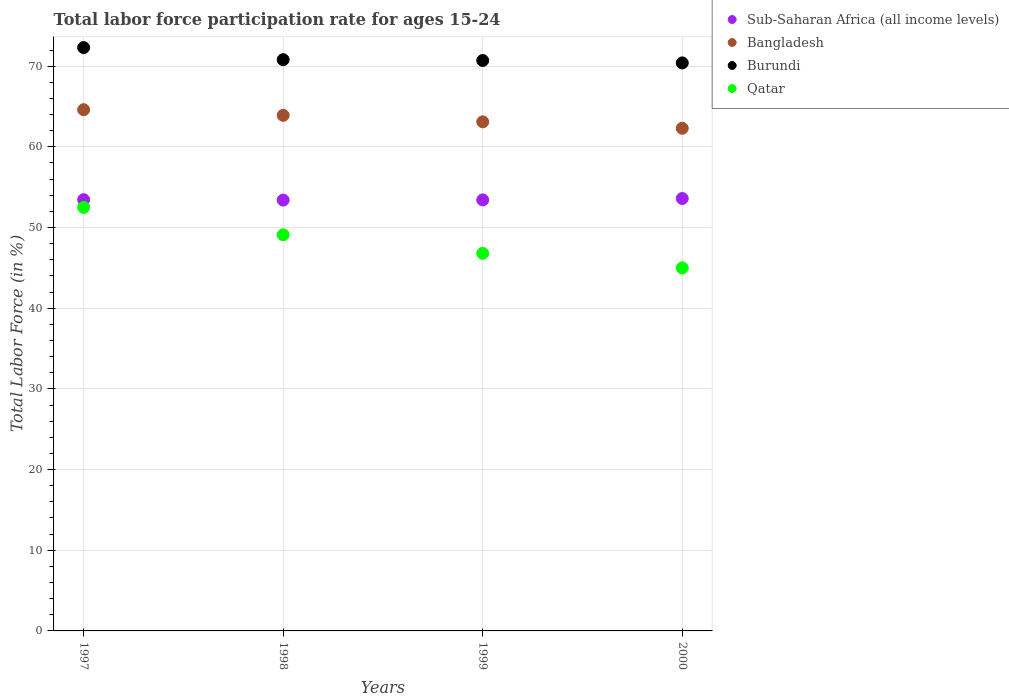How many different coloured dotlines are there?
Your response must be concise. 4. What is the labor force participation rate in Bangladesh in 1997?
Your answer should be compact. 64.6. Across all years, what is the maximum labor force participation rate in Bangladesh?
Keep it short and to the point. 64.6. Across all years, what is the minimum labor force participation rate in Bangladesh?
Your answer should be compact. 62.3. In which year was the labor force participation rate in Burundi maximum?
Give a very brief answer. 1997. What is the total labor force participation rate in Qatar in the graph?
Offer a terse response. 193.4. What is the difference between the labor force participation rate in Qatar in 1998 and that in 2000?
Provide a succinct answer. 4.1. What is the difference between the labor force participation rate in Bangladesh in 1999 and the labor force participation rate in Qatar in 2000?
Your answer should be compact. 18.1. What is the average labor force participation rate in Sub-Saharan Africa (all income levels) per year?
Your response must be concise. 53.47. In the year 2000, what is the difference between the labor force participation rate in Qatar and labor force participation rate in Sub-Saharan Africa (all income levels)?
Offer a very short reply. -8.6. What is the ratio of the labor force participation rate in Burundi in 1997 to that in 1998?
Offer a terse response. 1.02. Is the labor force participation rate in Burundi in 1998 less than that in 1999?
Your response must be concise. No. What is the difference between the highest and the second highest labor force participation rate in Sub-Saharan Africa (all income levels)?
Your response must be concise. 0.15. What is the difference between the highest and the lowest labor force participation rate in Bangladesh?
Your answer should be compact. 2.3. Does the labor force participation rate in Bangladesh monotonically increase over the years?
Ensure brevity in your answer.  No. Does the graph contain any zero values?
Your response must be concise. No. Does the graph contain grids?
Your response must be concise. Yes. What is the title of the graph?
Offer a terse response. Total labor force participation rate for ages 15-24. What is the label or title of the X-axis?
Your answer should be very brief. Years. What is the label or title of the Y-axis?
Your answer should be very brief. Total Labor Force (in %). What is the Total Labor Force (in %) in Sub-Saharan Africa (all income levels) in 1997?
Provide a succinct answer. 53.45. What is the Total Labor Force (in %) of Bangladesh in 1997?
Make the answer very short. 64.6. What is the Total Labor Force (in %) of Burundi in 1997?
Keep it short and to the point. 72.3. What is the Total Labor Force (in %) of Qatar in 1997?
Offer a very short reply. 52.5. What is the Total Labor Force (in %) of Sub-Saharan Africa (all income levels) in 1998?
Make the answer very short. 53.4. What is the Total Labor Force (in %) in Bangladesh in 1998?
Make the answer very short. 63.9. What is the Total Labor Force (in %) of Burundi in 1998?
Offer a very short reply. 70.8. What is the Total Labor Force (in %) in Qatar in 1998?
Your response must be concise. 49.1. What is the Total Labor Force (in %) of Sub-Saharan Africa (all income levels) in 1999?
Offer a very short reply. 53.42. What is the Total Labor Force (in %) of Bangladesh in 1999?
Offer a terse response. 63.1. What is the Total Labor Force (in %) in Burundi in 1999?
Your response must be concise. 70.7. What is the Total Labor Force (in %) in Qatar in 1999?
Ensure brevity in your answer.  46.8. What is the Total Labor Force (in %) of Sub-Saharan Africa (all income levels) in 2000?
Give a very brief answer. 53.6. What is the Total Labor Force (in %) in Bangladesh in 2000?
Your answer should be very brief. 62.3. What is the Total Labor Force (in %) in Burundi in 2000?
Ensure brevity in your answer.  70.4. Across all years, what is the maximum Total Labor Force (in %) in Sub-Saharan Africa (all income levels)?
Provide a succinct answer. 53.6. Across all years, what is the maximum Total Labor Force (in %) of Bangladesh?
Ensure brevity in your answer.  64.6. Across all years, what is the maximum Total Labor Force (in %) in Burundi?
Ensure brevity in your answer.  72.3. Across all years, what is the maximum Total Labor Force (in %) in Qatar?
Offer a very short reply. 52.5. Across all years, what is the minimum Total Labor Force (in %) in Sub-Saharan Africa (all income levels)?
Ensure brevity in your answer.  53.4. Across all years, what is the minimum Total Labor Force (in %) of Bangladesh?
Provide a succinct answer. 62.3. Across all years, what is the minimum Total Labor Force (in %) of Burundi?
Offer a very short reply. 70.4. What is the total Total Labor Force (in %) in Sub-Saharan Africa (all income levels) in the graph?
Your answer should be very brief. 213.86. What is the total Total Labor Force (in %) of Bangladesh in the graph?
Offer a very short reply. 253.9. What is the total Total Labor Force (in %) of Burundi in the graph?
Provide a short and direct response. 284.2. What is the total Total Labor Force (in %) of Qatar in the graph?
Give a very brief answer. 193.4. What is the difference between the Total Labor Force (in %) in Sub-Saharan Africa (all income levels) in 1997 and that in 1998?
Offer a very short reply. 0.05. What is the difference between the Total Labor Force (in %) of Bangladesh in 1997 and that in 1998?
Provide a succinct answer. 0.7. What is the difference between the Total Labor Force (in %) in Qatar in 1997 and that in 1998?
Provide a succinct answer. 3.4. What is the difference between the Total Labor Force (in %) in Sub-Saharan Africa (all income levels) in 1997 and that in 1999?
Your answer should be compact. 0.03. What is the difference between the Total Labor Force (in %) of Burundi in 1997 and that in 1999?
Your answer should be very brief. 1.6. What is the difference between the Total Labor Force (in %) in Sub-Saharan Africa (all income levels) in 1997 and that in 2000?
Keep it short and to the point. -0.15. What is the difference between the Total Labor Force (in %) of Bangladesh in 1997 and that in 2000?
Provide a short and direct response. 2.3. What is the difference between the Total Labor Force (in %) of Burundi in 1997 and that in 2000?
Ensure brevity in your answer.  1.9. What is the difference between the Total Labor Force (in %) of Sub-Saharan Africa (all income levels) in 1998 and that in 1999?
Provide a succinct answer. -0.02. What is the difference between the Total Labor Force (in %) of Burundi in 1998 and that in 1999?
Your answer should be very brief. 0.1. What is the difference between the Total Labor Force (in %) in Sub-Saharan Africa (all income levels) in 1998 and that in 2000?
Offer a terse response. -0.2. What is the difference between the Total Labor Force (in %) of Sub-Saharan Africa (all income levels) in 1999 and that in 2000?
Your answer should be compact. -0.18. What is the difference between the Total Labor Force (in %) of Sub-Saharan Africa (all income levels) in 1997 and the Total Labor Force (in %) of Bangladesh in 1998?
Offer a very short reply. -10.45. What is the difference between the Total Labor Force (in %) of Sub-Saharan Africa (all income levels) in 1997 and the Total Labor Force (in %) of Burundi in 1998?
Offer a very short reply. -17.35. What is the difference between the Total Labor Force (in %) in Sub-Saharan Africa (all income levels) in 1997 and the Total Labor Force (in %) in Qatar in 1998?
Give a very brief answer. 4.35. What is the difference between the Total Labor Force (in %) of Bangladesh in 1997 and the Total Labor Force (in %) of Burundi in 1998?
Provide a short and direct response. -6.2. What is the difference between the Total Labor Force (in %) of Bangladesh in 1997 and the Total Labor Force (in %) of Qatar in 1998?
Offer a terse response. 15.5. What is the difference between the Total Labor Force (in %) in Burundi in 1997 and the Total Labor Force (in %) in Qatar in 1998?
Your answer should be very brief. 23.2. What is the difference between the Total Labor Force (in %) of Sub-Saharan Africa (all income levels) in 1997 and the Total Labor Force (in %) of Bangladesh in 1999?
Offer a very short reply. -9.65. What is the difference between the Total Labor Force (in %) of Sub-Saharan Africa (all income levels) in 1997 and the Total Labor Force (in %) of Burundi in 1999?
Give a very brief answer. -17.25. What is the difference between the Total Labor Force (in %) in Sub-Saharan Africa (all income levels) in 1997 and the Total Labor Force (in %) in Qatar in 1999?
Provide a short and direct response. 6.65. What is the difference between the Total Labor Force (in %) of Bangladesh in 1997 and the Total Labor Force (in %) of Burundi in 1999?
Your response must be concise. -6.1. What is the difference between the Total Labor Force (in %) of Bangladesh in 1997 and the Total Labor Force (in %) of Qatar in 1999?
Make the answer very short. 17.8. What is the difference between the Total Labor Force (in %) in Burundi in 1997 and the Total Labor Force (in %) in Qatar in 1999?
Offer a very short reply. 25.5. What is the difference between the Total Labor Force (in %) of Sub-Saharan Africa (all income levels) in 1997 and the Total Labor Force (in %) of Bangladesh in 2000?
Your answer should be very brief. -8.85. What is the difference between the Total Labor Force (in %) in Sub-Saharan Africa (all income levels) in 1997 and the Total Labor Force (in %) in Burundi in 2000?
Offer a very short reply. -16.95. What is the difference between the Total Labor Force (in %) in Sub-Saharan Africa (all income levels) in 1997 and the Total Labor Force (in %) in Qatar in 2000?
Make the answer very short. 8.45. What is the difference between the Total Labor Force (in %) in Bangladesh in 1997 and the Total Labor Force (in %) in Qatar in 2000?
Your answer should be compact. 19.6. What is the difference between the Total Labor Force (in %) of Burundi in 1997 and the Total Labor Force (in %) of Qatar in 2000?
Your answer should be compact. 27.3. What is the difference between the Total Labor Force (in %) in Sub-Saharan Africa (all income levels) in 1998 and the Total Labor Force (in %) in Bangladesh in 1999?
Your response must be concise. -9.7. What is the difference between the Total Labor Force (in %) of Sub-Saharan Africa (all income levels) in 1998 and the Total Labor Force (in %) of Burundi in 1999?
Give a very brief answer. -17.3. What is the difference between the Total Labor Force (in %) in Sub-Saharan Africa (all income levels) in 1998 and the Total Labor Force (in %) in Qatar in 1999?
Ensure brevity in your answer.  6.6. What is the difference between the Total Labor Force (in %) in Bangladesh in 1998 and the Total Labor Force (in %) in Burundi in 1999?
Provide a succinct answer. -6.8. What is the difference between the Total Labor Force (in %) in Bangladesh in 1998 and the Total Labor Force (in %) in Qatar in 1999?
Your response must be concise. 17.1. What is the difference between the Total Labor Force (in %) of Burundi in 1998 and the Total Labor Force (in %) of Qatar in 1999?
Keep it short and to the point. 24. What is the difference between the Total Labor Force (in %) of Sub-Saharan Africa (all income levels) in 1998 and the Total Labor Force (in %) of Bangladesh in 2000?
Offer a very short reply. -8.9. What is the difference between the Total Labor Force (in %) in Sub-Saharan Africa (all income levels) in 1998 and the Total Labor Force (in %) in Burundi in 2000?
Give a very brief answer. -17. What is the difference between the Total Labor Force (in %) in Sub-Saharan Africa (all income levels) in 1998 and the Total Labor Force (in %) in Qatar in 2000?
Your response must be concise. 8.4. What is the difference between the Total Labor Force (in %) in Bangladesh in 1998 and the Total Labor Force (in %) in Burundi in 2000?
Keep it short and to the point. -6.5. What is the difference between the Total Labor Force (in %) in Burundi in 1998 and the Total Labor Force (in %) in Qatar in 2000?
Provide a succinct answer. 25.8. What is the difference between the Total Labor Force (in %) of Sub-Saharan Africa (all income levels) in 1999 and the Total Labor Force (in %) of Bangladesh in 2000?
Keep it short and to the point. -8.88. What is the difference between the Total Labor Force (in %) of Sub-Saharan Africa (all income levels) in 1999 and the Total Labor Force (in %) of Burundi in 2000?
Offer a very short reply. -16.98. What is the difference between the Total Labor Force (in %) in Sub-Saharan Africa (all income levels) in 1999 and the Total Labor Force (in %) in Qatar in 2000?
Ensure brevity in your answer.  8.42. What is the difference between the Total Labor Force (in %) in Burundi in 1999 and the Total Labor Force (in %) in Qatar in 2000?
Offer a terse response. 25.7. What is the average Total Labor Force (in %) of Sub-Saharan Africa (all income levels) per year?
Keep it short and to the point. 53.47. What is the average Total Labor Force (in %) of Bangladesh per year?
Keep it short and to the point. 63.48. What is the average Total Labor Force (in %) of Burundi per year?
Keep it short and to the point. 71.05. What is the average Total Labor Force (in %) in Qatar per year?
Your answer should be compact. 48.35. In the year 1997, what is the difference between the Total Labor Force (in %) in Sub-Saharan Africa (all income levels) and Total Labor Force (in %) in Bangladesh?
Make the answer very short. -11.15. In the year 1997, what is the difference between the Total Labor Force (in %) of Sub-Saharan Africa (all income levels) and Total Labor Force (in %) of Burundi?
Keep it short and to the point. -18.85. In the year 1997, what is the difference between the Total Labor Force (in %) of Sub-Saharan Africa (all income levels) and Total Labor Force (in %) of Qatar?
Your answer should be very brief. 0.95. In the year 1997, what is the difference between the Total Labor Force (in %) of Bangladesh and Total Labor Force (in %) of Burundi?
Provide a short and direct response. -7.7. In the year 1997, what is the difference between the Total Labor Force (in %) of Burundi and Total Labor Force (in %) of Qatar?
Your answer should be compact. 19.8. In the year 1998, what is the difference between the Total Labor Force (in %) in Sub-Saharan Africa (all income levels) and Total Labor Force (in %) in Bangladesh?
Your response must be concise. -10.5. In the year 1998, what is the difference between the Total Labor Force (in %) in Sub-Saharan Africa (all income levels) and Total Labor Force (in %) in Burundi?
Make the answer very short. -17.4. In the year 1998, what is the difference between the Total Labor Force (in %) in Sub-Saharan Africa (all income levels) and Total Labor Force (in %) in Qatar?
Provide a short and direct response. 4.3. In the year 1998, what is the difference between the Total Labor Force (in %) in Burundi and Total Labor Force (in %) in Qatar?
Your answer should be very brief. 21.7. In the year 1999, what is the difference between the Total Labor Force (in %) of Sub-Saharan Africa (all income levels) and Total Labor Force (in %) of Bangladesh?
Keep it short and to the point. -9.68. In the year 1999, what is the difference between the Total Labor Force (in %) in Sub-Saharan Africa (all income levels) and Total Labor Force (in %) in Burundi?
Give a very brief answer. -17.28. In the year 1999, what is the difference between the Total Labor Force (in %) in Sub-Saharan Africa (all income levels) and Total Labor Force (in %) in Qatar?
Your answer should be compact. 6.62. In the year 1999, what is the difference between the Total Labor Force (in %) in Burundi and Total Labor Force (in %) in Qatar?
Your answer should be compact. 23.9. In the year 2000, what is the difference between the Total Labor Force (in %) in Sub-Saharan Africa (all income levels) and Total Labor Force (in %) in Bangladesh?
Make the answer very short. -8.7. In the year 2000, what is the difference between the Total Labor Force (in %) in Sub-Saharan Africa (all income levels) and Total Labor Force (in %) in Burundi?
Your response must be concise. -16.8. In the year 2000, what is the difference between the Total Labor Force (in %) of Sub-Saharan Africa (all income levels) and Total Labor Force (in %) of Qatar?
Ensure brevity in your answer.  8.6. In the year 2000, what is the difference between the Total Labor Force (in %) of Bangladesh and Total Labor Force (in %) of Burundi?
Offer a terse response. -8.1. In the year 2000, what is the difference between the Total Labor Force (in %) of Burundi and Total Labor Force (in %) of Qatar?
Make the answer very short. 25.4. What is the ratio of the Total Labor Force (in %) in Bangladesh in 1997 to that in 1998?
Your answer should be compact. 1.01. What is the ratio of the Total Labor Force (in %) in Burundi in 1997 to that in 1998?
Provide a short and direct response. 1.02. What is the ratio of the Total Labor Force (in %) in Qatar in 1997 to that in 1998?
Provide a succinct answer. 1.07. What is the ratio of the Total Labor Force (in %) of Sub-Saharan Africa (all income levels) in 1997 to that in 1999?
Offer a terse response. 1. What is the ratio of the Total Labor Force (in %) in Bangladesh in 1997 to that in 1999?
Your answer should be compact. 1.02. What is the ratio of the Total Labor Force (in %) of Burundi in 1997 to that in 1999?
Your answer should be very brief. 1.02. What is the ratio of the Total Labor Force (in %) in Qatar in 1997 to that in 1999?
Provide a succinct answer. 1.12. What is the ratio of the Total Labor Force (in %) in Sub-Saharan Africa (all income levels) in 1997 to that in 2000?
Your response must be concise. 1. What is the ratio of the Total Labor Force (in %) in Bangladesh in 1997 to that in 2000?
Your answer should be very brief. 1.04. What is the ratio of the Total Labor Force (in %) in Burundi in 1997 to that in 2000?
Your answer should be very brief. 1.03. What is the ratio of the Total Labor Force (in %) of Qatar in 1997 to that in 2000?
Keep it short and to the point. 1.17. What is the ratio of the Total Labor Force (in %) of Bangladesh in 1998 to that in 1999?
Make the answer very short. 1.01. What is the ratio of the Total Labor Force (in %) of Burundi in 1998 to that in 1999?
Offer a very short reply. 1. What is the ratio of the Total Labor Force (in %) in Qatar in 1998 to that in 1999?
Keep it short and to the point. 1.05. What is the ratio of the Total Labor Force (in %) of Sub-Saharan Africa (all income levels) in 1998 to that in 2000?
Keep it short and to the point. 1. What is the ratio of the Total Labor Force (in %) of Bangladesh in 1998 to that in 2000?
Your response must be concise. 1.03. What is the ratio of the Total Labor Force (in %) in Qatar in 1998 to that in 2000?
Your answer should be very brief. 1.09. What is the ratio of the Total Labor Force (in %) of Sub-Saharan Africa (all income levels) in 1999 to that in 2000?
Offer a very short reply. 1. What is the ratio of the Total Labor Force (in %) in Bangladesh in 1999 to that in 2000?
Keep it short and to the point. 1.01. What is the ratio of the Total Labor Force (in %) in Qatar in 1999 to that in 2000?
Ensure brevity in your answer.  1.04. What is the difference between the highest and the second highest Total Labor Force (in %) of Sub-Saharan Africa (all income levels)?
Ensure brevity in your answer.  0.15. What is the difference between the highest and the second highest Total Labor Force (in %) of Bangladesh?
Make the answer very short. 0.7. What is the difference between the highest and the second highest Total Labor Force (in %) in Burundi?
Keep it short and to the point. 1.5. What is the difference between the highest and the second highest Total Labor Force (in %) in Qatar?
Ensure brevity in your answer.  3.4. What is the difference between the highest and the lowest Total Labor Force (in %) of Sub-Saharan Africa (all income levels)?
Offer a very short reply. 0.2. What is the difference between the highest and the lowest Total Labor Force (in %) of Burundi?
Give a very brief answer. 1.9. What is the difference between the highest and the lowest Total Labor Force (in %) in Qatar?
Offer a terse response. 7.5. 